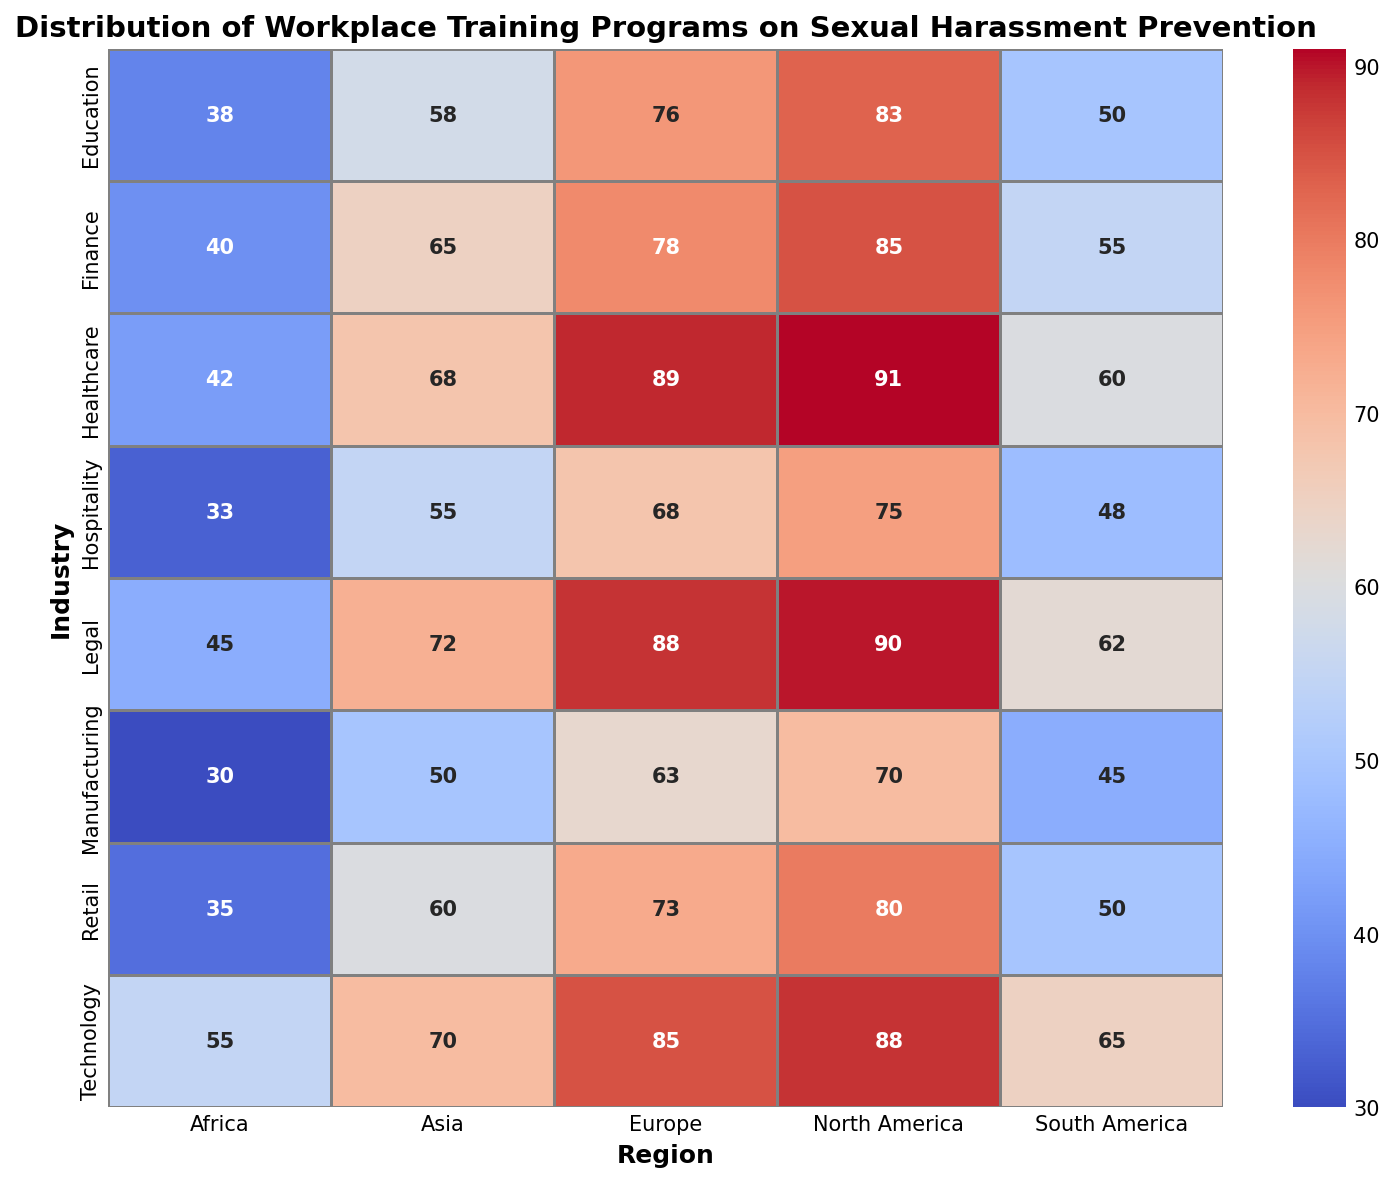Which industry has the highest number of workplace training programs in North America? To find this, locate the values in the "North America" column and identify the highest number within the "Industry" rows. The highest value is 91 under "Healthcare."
Answer: Healthcare What is the difference in the number of training programs between the Finance industry in Europe and Asia? Find the Finance values for Europe and Asia (78 and 65, respectively) and subtract the smaller number from the larger one: 78 - 65 = 13.
Answer: 13 Which region has the least number of workplace training programs in the Education industry? Look at the Education row and identify the lowest value among the regions. The smallest number is 38 in "Africa."
Answer: Africa Which two industries have a training program difference of 10 or less in South America? Identify values in the "South America" column and find pairs with a difference of ≤10. Here, "Finance (55)" and "Education (50)" have a difference of 5, and "Retail (50)" and "Technology (65)" have a difference of 15, but only "Finance and Education" is within the allowed range.
Answer: Finance and Education What is the average number of training programs across all industries in Europe? Sum the values for Europe across all industries and divide by the number of industries. Values: 78 + 89 + 76 + 63 + 85 + 68 + 73 + 88 = 620. Number of industries = 8. So, the average is 620/8 = 77.5.
Answer: 77.5 In which region does the Manufacturing industry have the highest number of workplace training programs? Look at the Manufacturing row and identify the highest value among the regions. The highest value is 70 in "North America."
Answer: North America Which industry has more training programs in Asia: Legal or Technology? Compare the values for "Legal" (72) and "Technology" (70) in the "Asia" column. 72 is greater than 70, so "Legal" has more.
Answer: Legal What is the difference between the industry with the most and the least training programs in Africa? Identify the highest and lowest values in the "Africa" column: "Legal (45)" and "Manufacturing (30)." Subtract the smaller from the larger: 45 - 30 = 15.
Answer: 15 How many industries have more than 60 training programs in South America? Count the values in the "South America" column that are greater than 60. Identified values are: Legal (62), Technology (65). Only 2 industries meet this criterion.
Answer: 2 